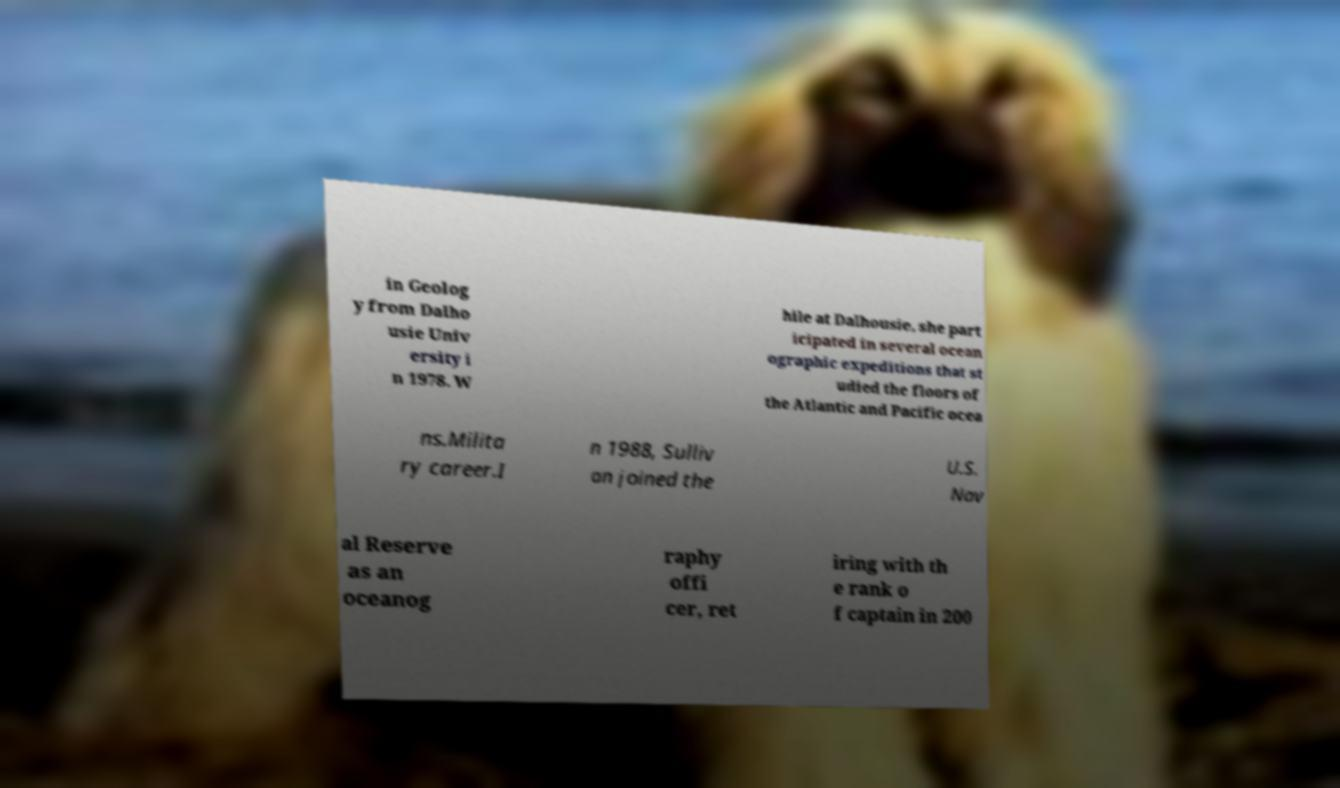I need the written content from this picture converted into text. Can you do that? in Geolog y from Dalho usie Univ ersity i n 1978. W hile at Dalhousie, she part icipated in several ocean ographic expeditions that st udied the floors of the Atlantic and Pacific ocea ns.Milita ry career.I n 1988, Sulliv an joined the U.S. Nav al Reserve as an oceanog raphy offi cer, ret iring with th e rank o f captain in 200 